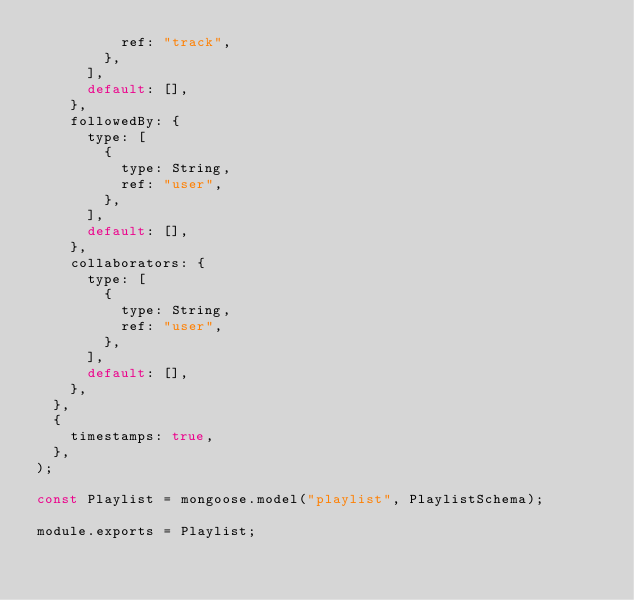Convert code to text. <code><loc_0><loc_0><loc_500><loc_500><_JavaScript_>          ref: "track",
        },
      ],
      default: [],
    },
    followedBy: {
      type: [
        {
          type: String,
          ref: "user",
        },
      ],
      default: [],
    },
    collaborators: {
      type: [
        {
          type: String,
          ref: "user",
        },
      ],
      default: [],
    },
  },
  {
    timestamps: true,
  },
);

const Playlist = mongoose.model("playlist", PlaylistSchema);

module.exports = Playlist;
</code> 